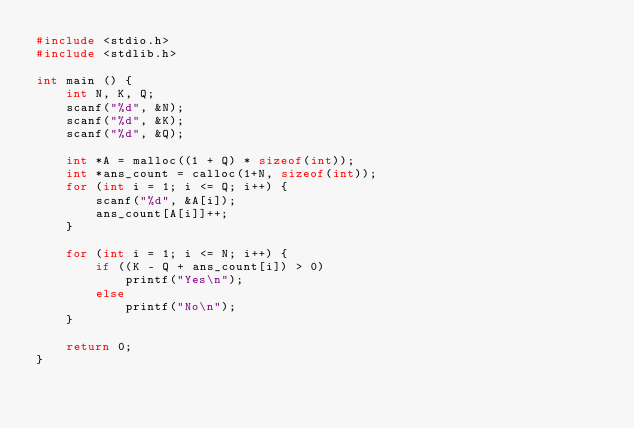<code> <loc_0><loc_0><loc_500><loc_500><_C_>#include <stdio.h>
#include <stdlib.h>

int main () {
    int N, K, Q;
    scanf("%d", &N);
    scanf("%d", &K);
    scanf("%d", &Q);

    int *A = malloc((1 + Q) * sizeof(int));
    int *ans_count = calloc(1+N, sizeof(int));
    for (int i = 1; i <= Q; i++) {
        scanf("%d", &A[i]);
        ans_count[A[i]]++;
    }

    for (int i = 1; i <= N; i++) {
        if ((K - Q + ans_count[i]) > 0)
            printf("Yes\n");
        else
            printf("No\n");
    }

    return 0;
}
</code> 